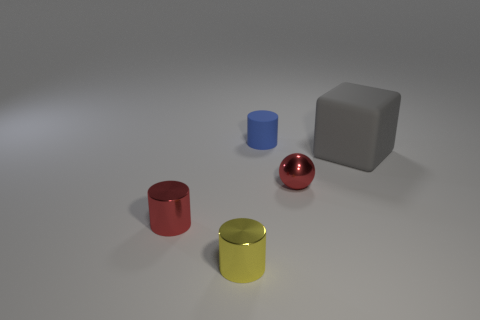Add 5 big yellow metal balls. How many objects exist? 10 Subtract all balls. How many objects are left? 4 Subtract 1 red spheres. How many objects are left? 4 Subtract all red rubber blocks. Subtract all rubber cylinders. How many objects are left? 4 Add 1 red metal balls. How many red metal balls are left? 2 Add 4 tiny matte cylinders. How many tiny matte cylinders exist? 5 